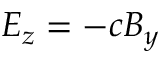Convert formula to latex. <formula><loc_0><loc_0><loc_500><loc_500>E _ { z } = - c B _ { y }</formula> 